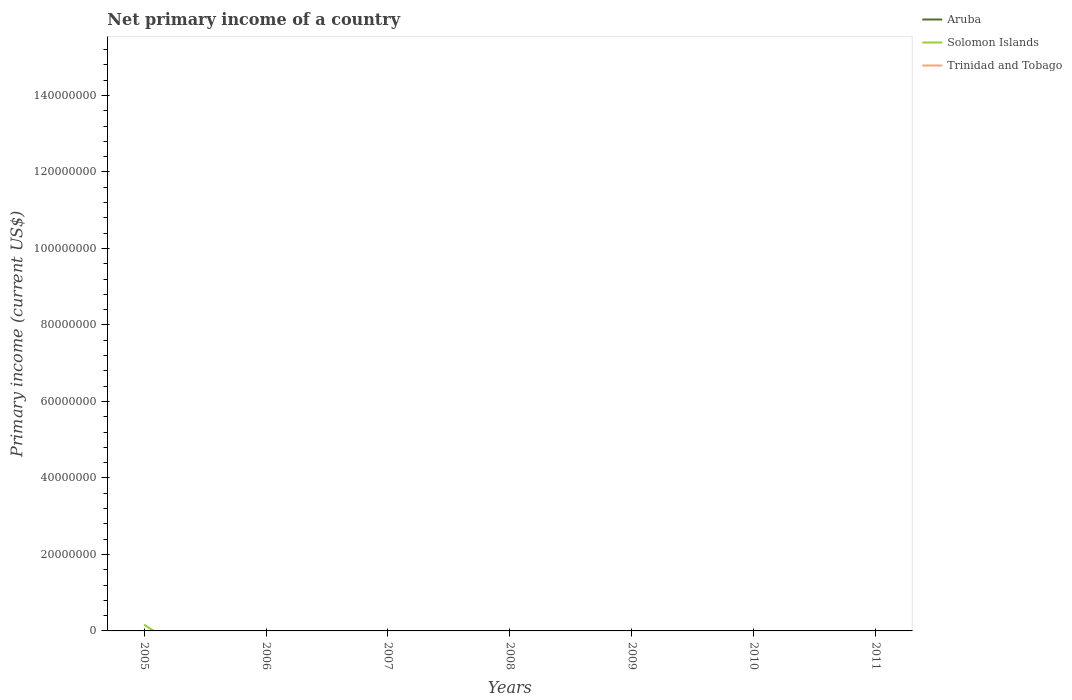How many different coloured lines are there?
Your response must be concise. 1. Does the line corresponding to Aruba intersect with the line corresponding to Solomon Islands?
Your response must be concise. Yes. Across all years, what is the maximum primary income in Solomon Islands?
Your response must be concise. 0. What is the difference between the highest and the second highest primary income in Solomon Islands?
Make the answer very short. 1.62e+06. What is the difference between the highest and the lowest primary income in Aruba?
Make the answer very short. 0. Is the primary income in Solomon Islands strictly greater than the primary income in Aruba over the years?
Offer a terse response. No. How many lines are there?
Ensure brevity in your answer.  1. How many years are there in the graph?
Your answer should be compact. 7. What is the difference between two consecutive major ticks on the Y-axis?
Provide a short and direct response. 2.00e+07. Are the values on the major ticks of Y-axis written in scientific E-notation?
Give a very brief answer. No. Does the graph contain any zero values?
Make the answer very short. Yes. What is the title of the graph?
Ensure brevity in your answer.  Net primary income of a country. Does "Equatorial Guinea" appear as one of the legend labels in the graph?
Provide a succinct answer. No. What is the label or title of the Y-axis?
Your response must be concise. Primary income (current US$). What is the Primary income (current US$) of Aruba in 2005?
Ensure brevity in your answer.  0. What is the Primary income (current US$) in Solomon Islands in 2005?
Your answer should be compact. 1.62e+06. What is the Primary income (current US$) of Aruba in 2006?
Provide a succinct answer. 0. What is the Primary income (current US$) in Solomon Islands in 2006?
Give a very brief answer. 0. What is the Primary income (current US$) in Trinidad and Tobago in 2006?
Keep it short and to the point. 0. What is the Primary income (current US$) in Trinidad and Tobago in 2007?
Your response must be concise. 0. What is the Primary income (current US$) of Aruba in 2008?
Keep it short and to the point. 0. What is the Primary income (current US$) in Aruba in 2009?
Offer a very short reply. 0. What is the Primary income (current US$) of Aruba in 2010?
Your response must be concise. 0. What is the Primary income (current US$) in Trinidad and Tobago in 2010?
Give a very brief answer. 0. What is the Primary income (current US$) of Solomon Islands in 2011?
Your response must be concise. 0. Across all years, what is the maximum Primary income (current US$) in Solomon Islands?
Ensure brevity in your answer.  1.62e+06. What is the total Primary income (current US$) in Solomon Islands in the graph?
Make the answer very short. 1.62e+06. What is the total Primary income (current US$) of Trinidad and Tobago in the graph?
Offer a very short reply. 0. What is the average Primary income (current US$) in Aruba per year?
Give a very brief answer. 0. What is the average Primary income (current US$) in Solomon Islands per year?
Your response must be concise. 2.31e+05. What is the difference between the highest and the lowest Primary income (current US$) of Solomon Islands?
Offer a very short reply. 1.62e+06. 